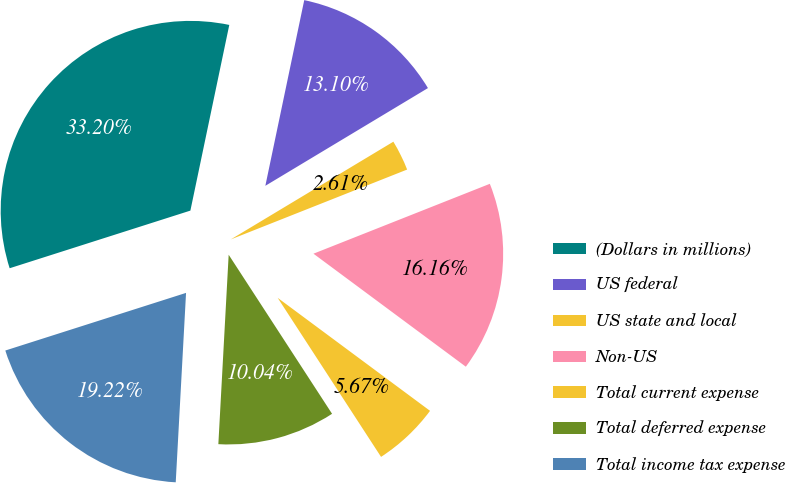<chart> <loc_0><loc_0><loc_500><loc_500><pie_chart><fcel>(Dollars in millions)<fcel>US federal<fcel>US state and local<fcel>Non-US<fcel>Total current expense<fcel>Total deferred expense<fcel>Total income tax expense<nl><fcel>33.2%<fcel>13.1%<fcel>2.61%<fcel>16.16%<fcel>5.67%<fcel>10.04%<fcel>19.22%<nl></chart> 